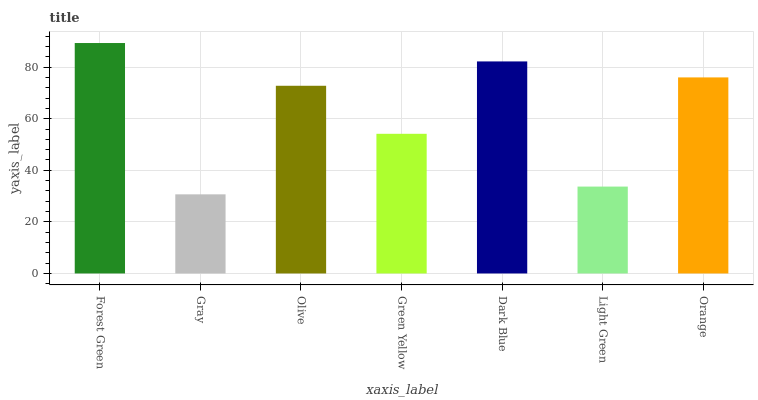Is Gray the minimum?
Answer yes or no. Yes. Is Forest Green the maximum?
Answer yes or no. Yes. Is Olive the minimum?
Answer yes or no. No. Is Olive the maximum?
Answer yes or no. No. Is Olive greater than Gray?
Answer yes or no. Yes. Is Gray less than Olive?
Answer yes or no. Yes. Is Gray greater than Olive?
Answer yes or no. No. Is Olive less than Gray?
Answer yes or no. No. Is Olive the high median?
Answer yes or no. Yes. Is Olive the low median?
Answer yes or no. Yes. Is Dark Blue the high median?
Answer yes or no. No. Is Forest Green the low median?
Answer yes or no. No. 